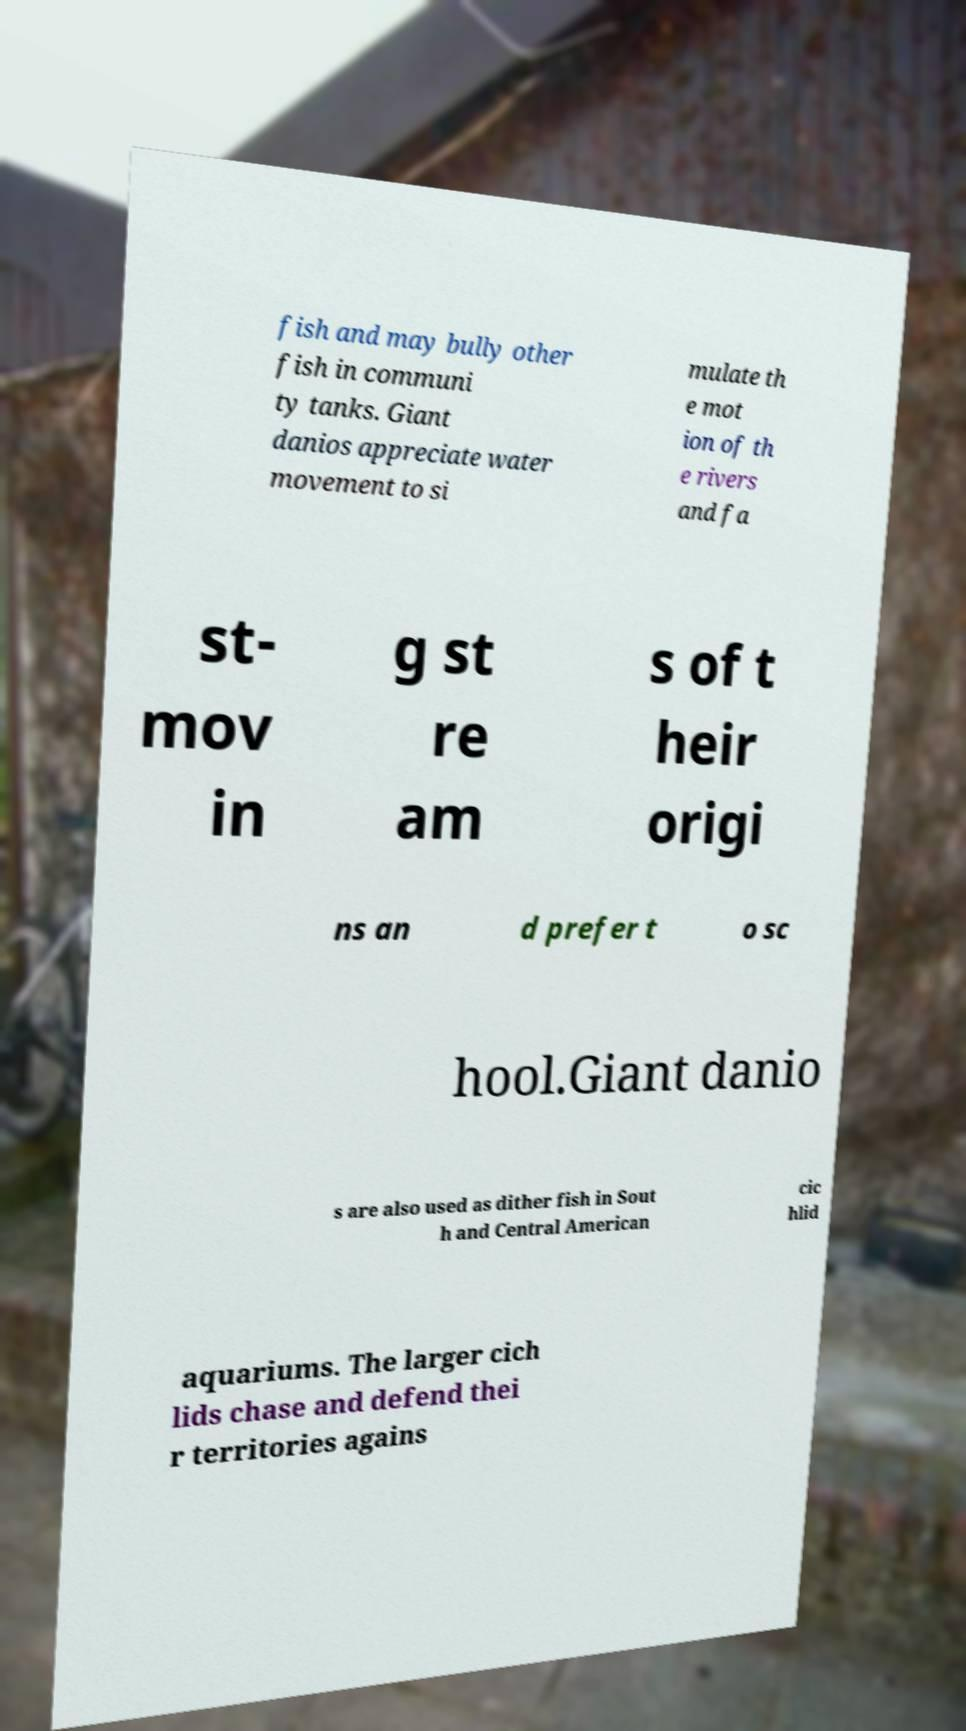For documentation purposes, I need the text within this image transcribed. Could you provide that? fish and may bully other fish in communi ty tanks. Giant danios appreciate water movement to si mulate th e mot ion of th e rivers and fa st- mov in g st re am s of t heir origi ns an d prefer t o sc hool.Giant danio s are also used as dither fish in Sout h and Central American cic hlid aquariums. The larger cich lids chase and defend thei r territories agains 